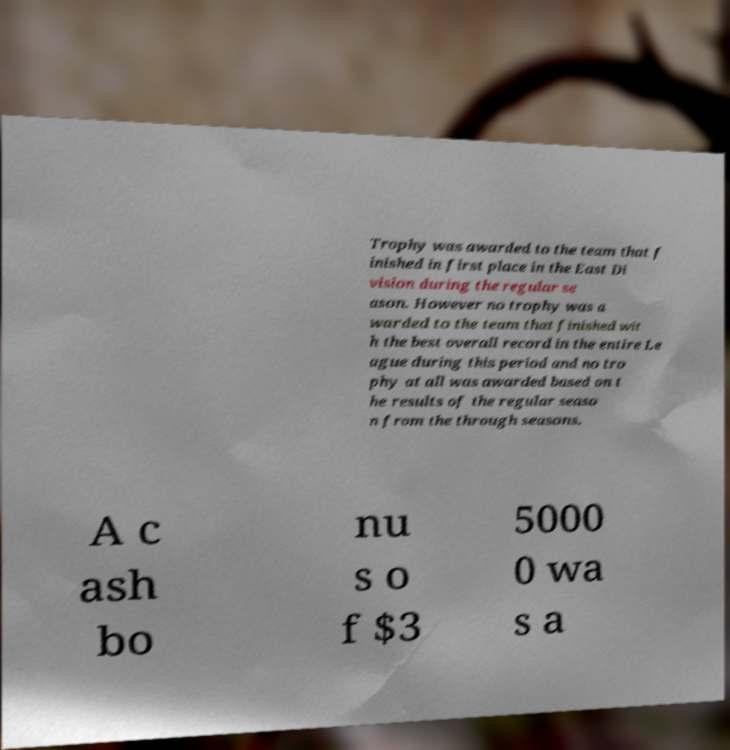There's text embedded in this image that I need extracted. Can you transcribe it verbatim? Trophy was awarded to the team that f inished in first place in the East Di vision during the regular se ason. However no trophy was a warded to the team that finished wit h the best overall record in the entire Le ague during this period and no tro phy at all was awarded based on t he results of the regular seaso n from the through seasons. A c ash bo nu s o f $3 5000 0 wa s a 